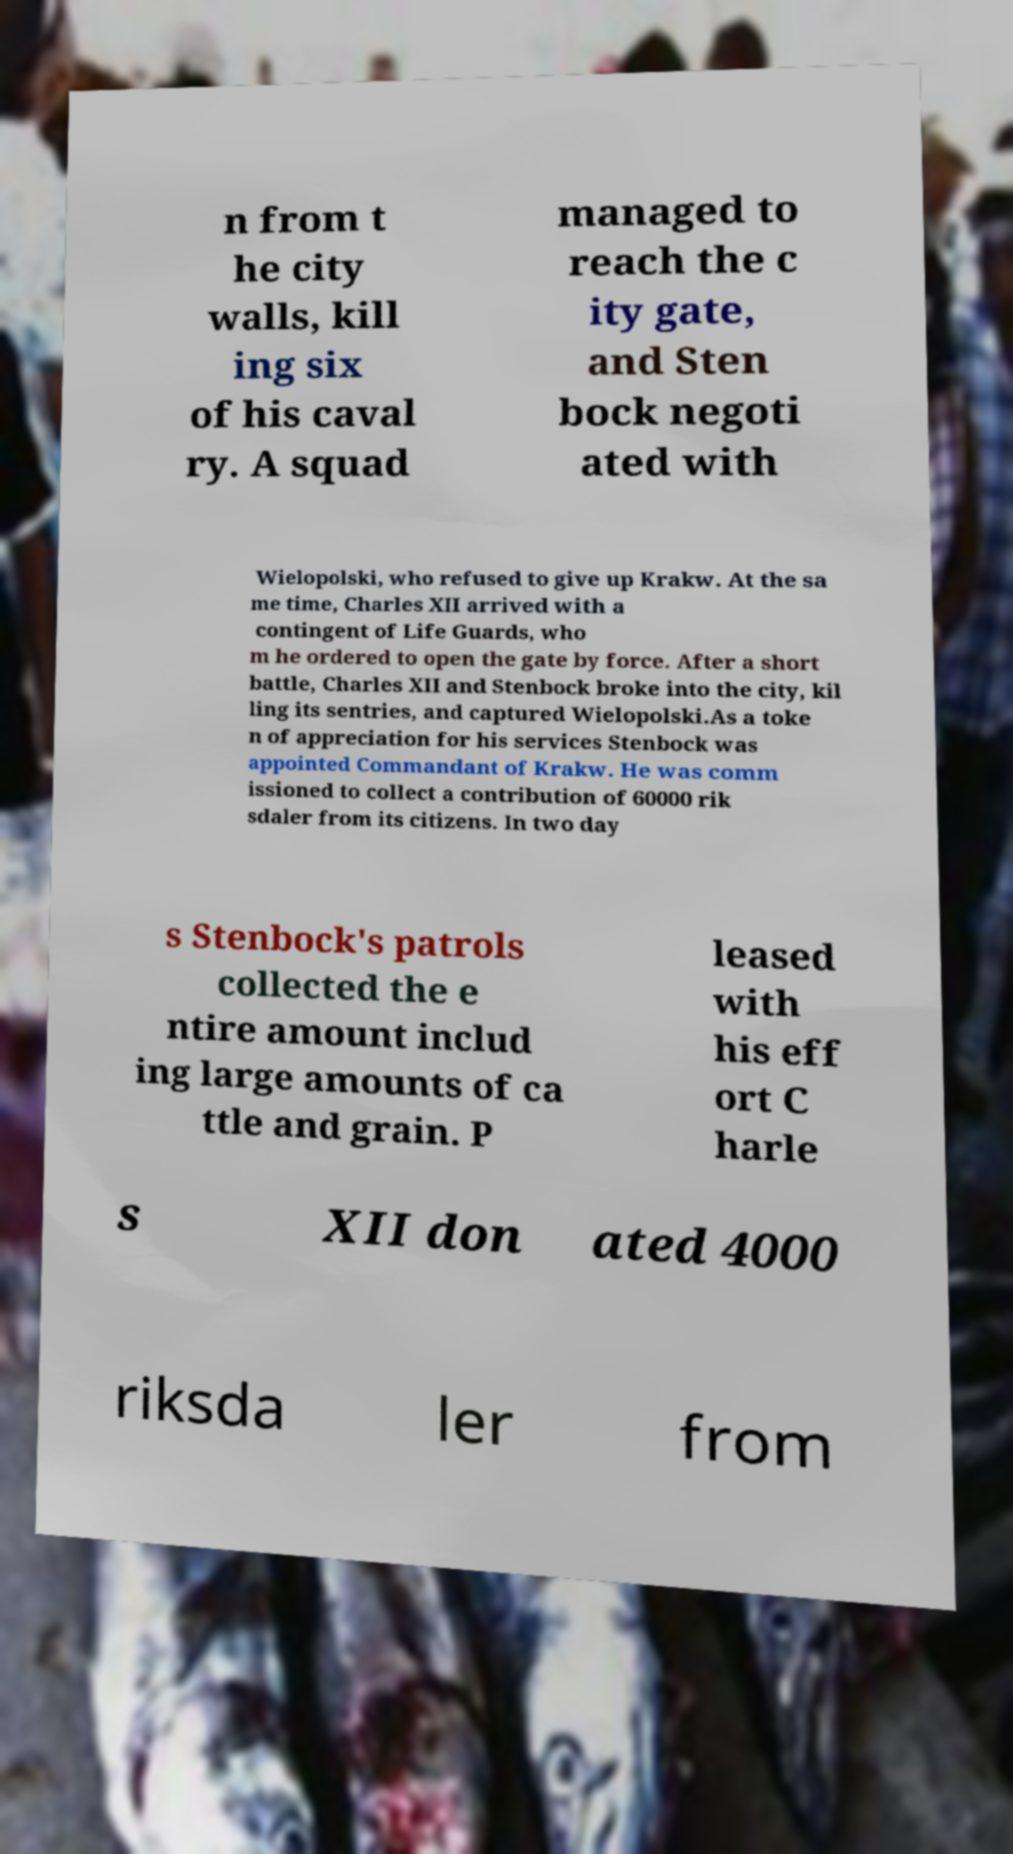There's text embedded in this image that I need extracted. Can you transcribe it verbatim? n from t he city walls, kill ing six of his caval ry. A squad managed to reach the c ity gate, and Sten bock negoti ated with Wielopolski, who refused to give up Krakw. At the sa me time, Charles XII arrived with a contingent of Life Guards, who m he ordered to open the gate by force. After a short battle, Charles XII and Stenbock broke into the city, kil ling its sentries, and captured Wielopolski.As a toke n of appreciation for his services Stenbock was appointed Commandant of Krakw. He was comm issioned to collect a contribution of 60000 rik sdaler from its citizens. In two day s Stenbock's patrols collected the e ntire amount includ ing large amounts of ca ttle and grain. P leased with his eff ort C harle s XII don ated 4000 riksda ler from 